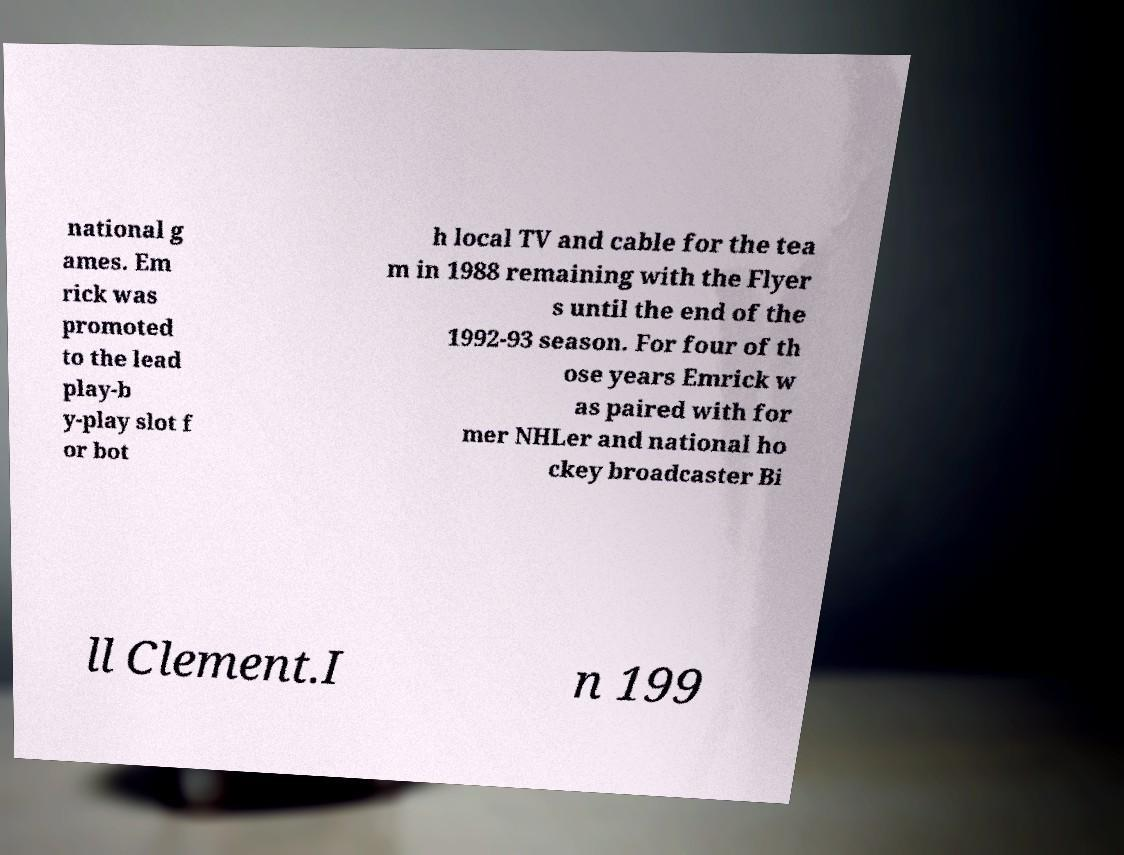Can you read and provide the text displayed in the image?This photo seems to have some interesting text. Can you extract and type it out for me? national g ames. Em rick was promoted to the lead play-b y-play slot f or bot h local TV and cable for the tea m in 1988 remaining with the Flyer s until the end of the 1992-93 season. For four of th ose years Emrick w as paired with for mer NHLer and national ho ckey broadcaster Bi ll Clement.I n 199 